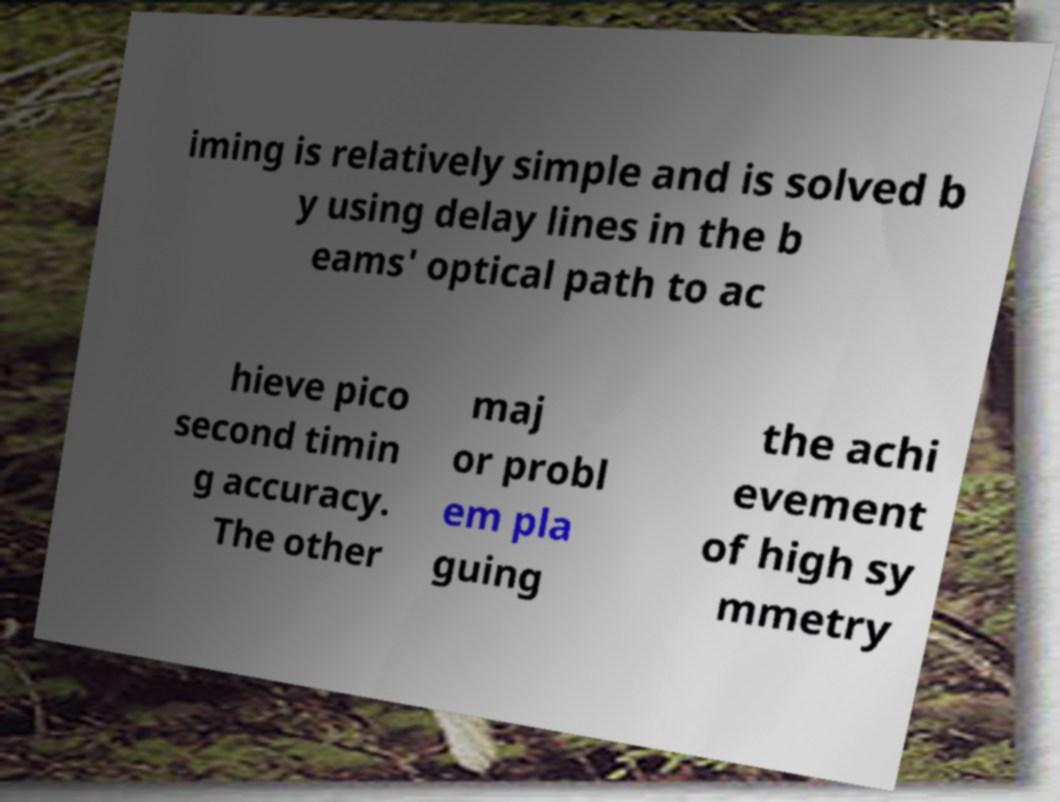What messages or text are displayed in this image? I need them in a readable, typed format. iming is relatively simple and is solved b y using delay lines in the b eams' optical path to ac hieve pico second timin g accuracy. The other maj or probl em pla guing the achi evement of high sy mmetry 